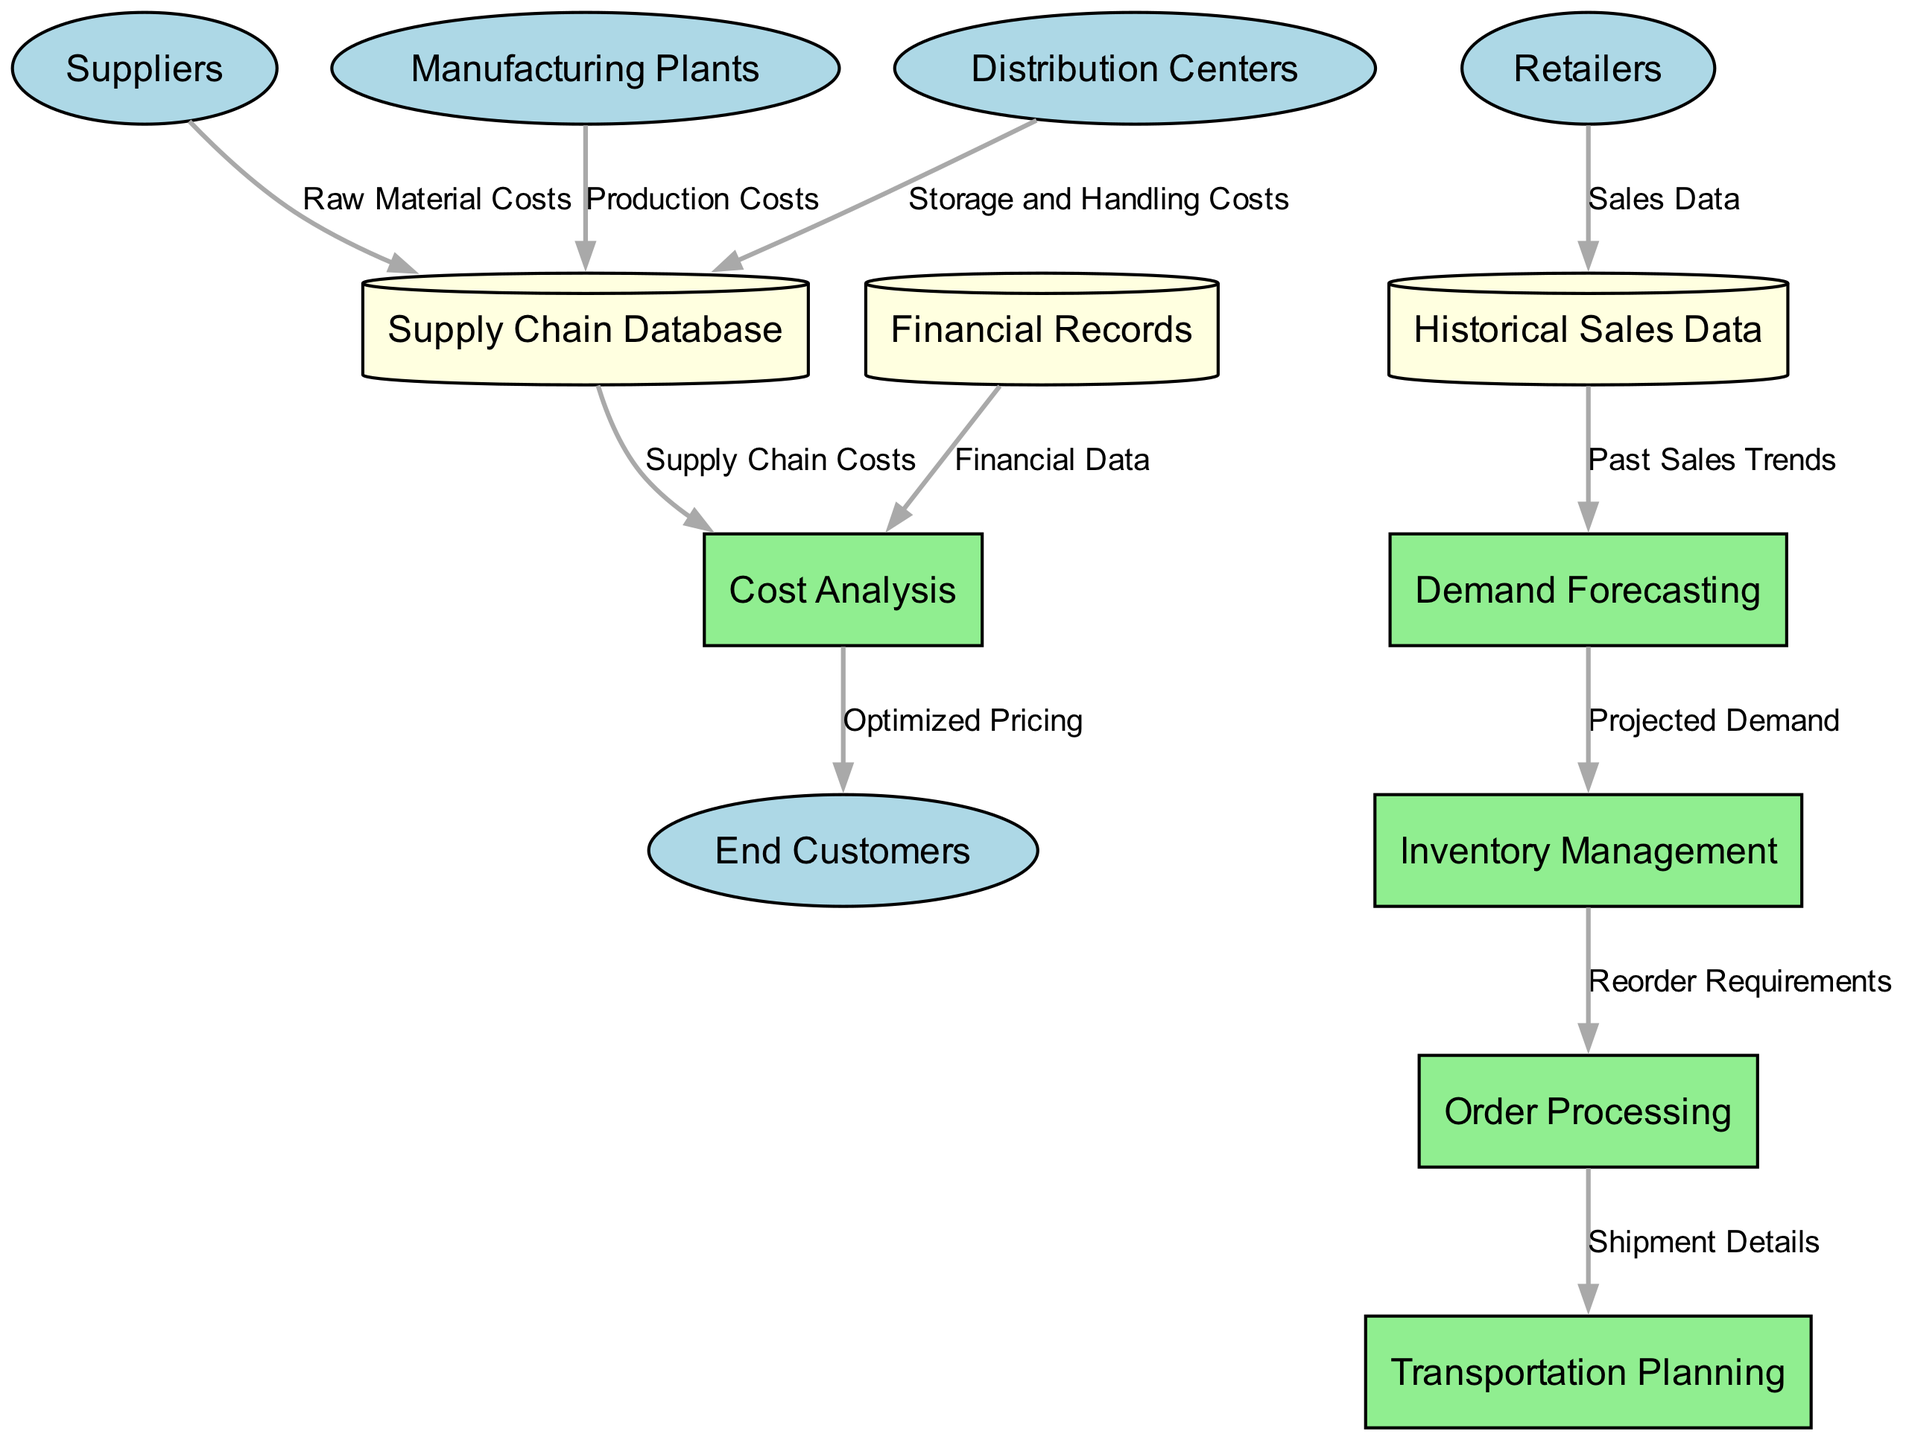What are the external entities in the diagram? The external entities mentioned in the diagram consist of five nodes: Suppliers, Manufacturing Plants, Distribution Centers, Retailers, and End Customers. These are the key parties involved in the supply chain process.
Answer: Suppliers, Manufacturing Plants, Distribution Centers, Retailers, End Customers How many processes are defined in the diagram? The diagram identifies five distinct processes: Demand Forecasting, Inventory Management, Order Processing, Transportation Planning, and Cost Analysis. By counting each one, we confirm the total number.
Answer: 5 What is the data flow from Suppliers to the Supply Chain Database? The data flow from Suppliers to the Supply Chain Database is labeled as "Raw Material Costs." This indicates that the suppliers provide the costs associated with raw materials to the database.
Answer: Raw Material Costs Which process receives the "Projected Demand"? The process that receives "Projected Demand" is Inventory Management. This flow indicates that inventory management relies on demand forecasts to plan for stock levels and order necessities.
Answer: Inventory Management How does the data flow from Financial Records contribute to the Cost Analysis process? Financial Records flow into Cost Analysis with the label "Financial Data." This indicates that the analysis of costs is based on financial data collected and stored, allowing for informed cost assessments and optimizations.
Answer: Financial Data Which entity provides data on "Sales Data"? The entity that provides "Sales Data" is Retailers. This flow highlights that retailers contribute their sales information to the Historical Sales Data store, which is critical for forecasting and inventory decisions.
Answer: Retailers What connects Inventory Management to Order Processing? The connection between Inventory Management and Order Processing is labeled as "Reorder Requirements." This indicates that inventory management determines when to reorder stock, which is essential for maintaining supply levels.
Answer: Reorder Requirements How many data stores are present in the diagram? In the diagram, there are three data stores: Supply Chain Database, Financial Records, and Historical Sales Data. Counting these reveals the total number of data repositories used in the system.
Answer: 3 What is the outcome of Cost Analysis directed to End Customers? The outcome labeled from Cost Analysis to End Customers is "Optimized Pricing." This indicates that after analyzing costs, the system determines suitable pricing for customers based on the optimization process.
Answer: Optimized Pricing What is the role of historical sales data in the demand forecasting process? Historical Sales Data plays the role of providing "Past Sales Trends" to the Demand Forecasting process. This information is crucial for making accurate projections about future demand.
Answer: Past Sales Trends 